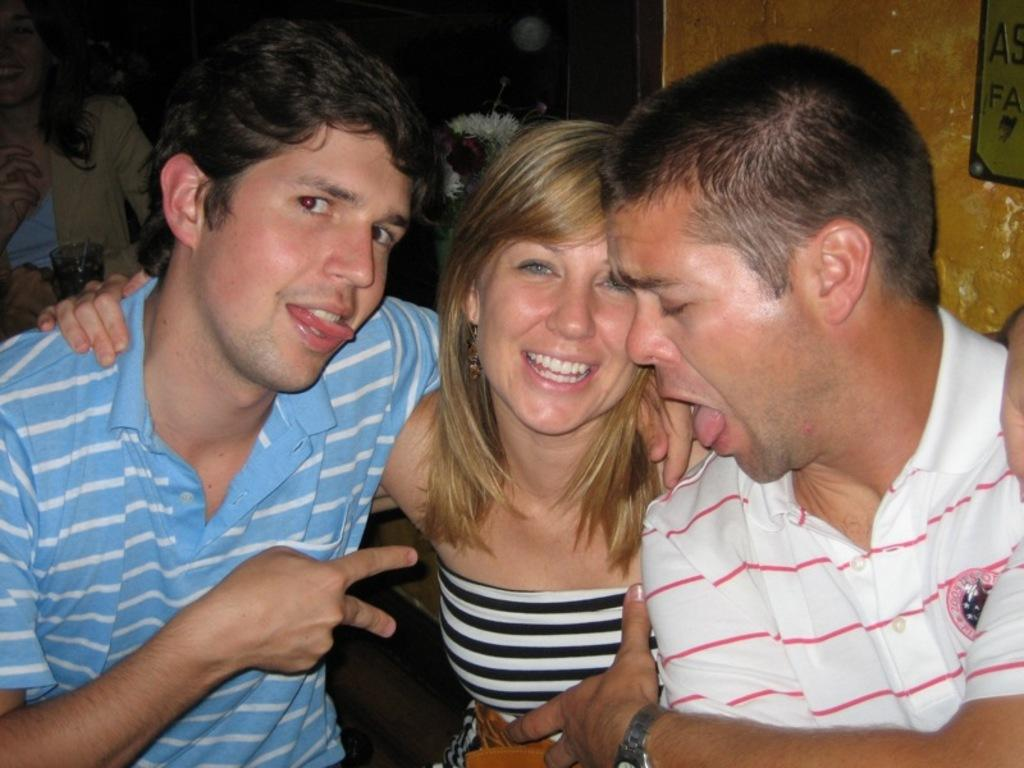How many people are present in the image? There are three people in the image. Can you describe the expression of one of the individuals? A woman is smiling in the image. What can be seen on the wall in the image? There is a board on a wall in the image. Can you describe the background of the image? There is a woman and a glass in the background of the image. What type of pickle is the woman holding in the image? There is no pickle present in the image. Are the three people in the image sisters? The provided facts do not mention any familial relationships between the individuals in the image. 